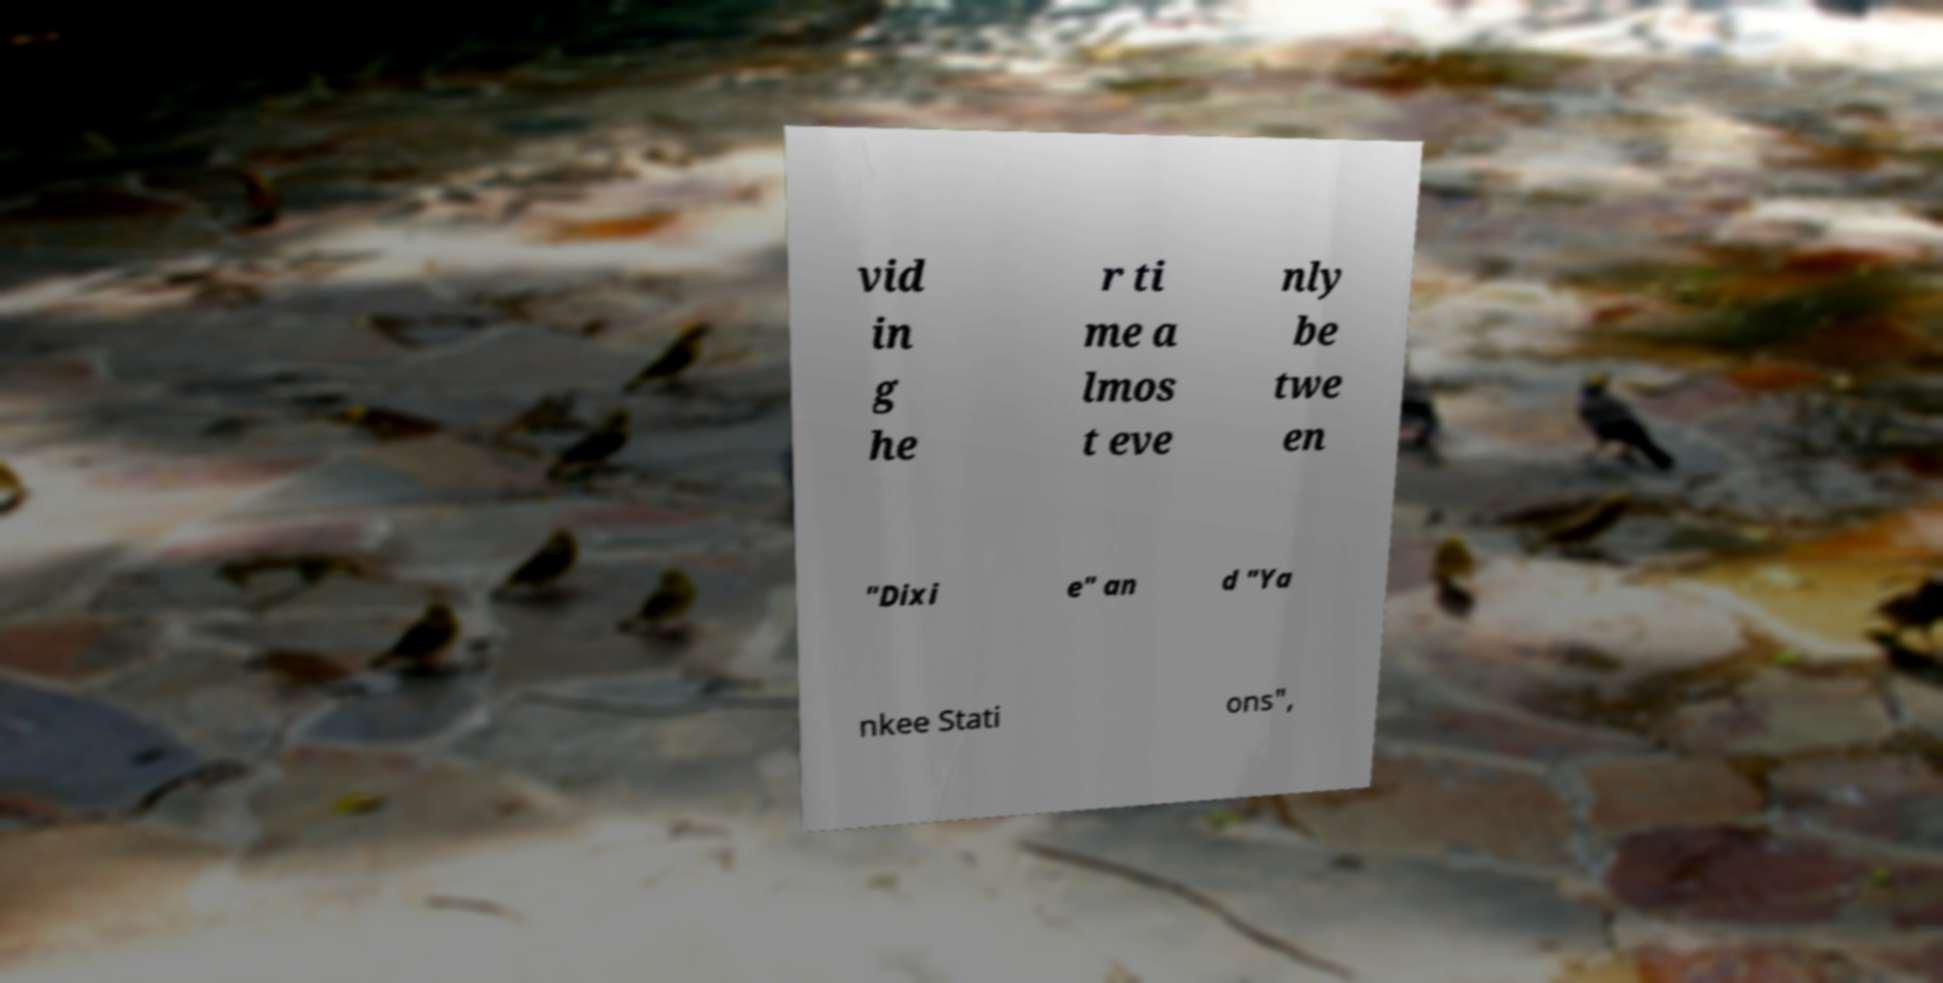Could you assist in decoding the text presented in this image and type it out clearly? vid in g he r ti me a lmos t eve nly be twe en "Dixi e" an d "Ya nkee Stati ons", 